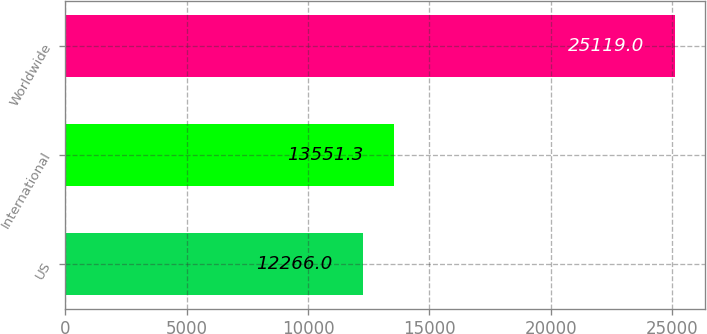Convert chart to OTSL. <chart><loc_0><loc_0><loc_500><loc_500><bar_chart><fcel>US<fcel>International<fcel>Worldwide<nl><fcel>12266<fcel>13551.3<fcel>25119<nl></chart> 